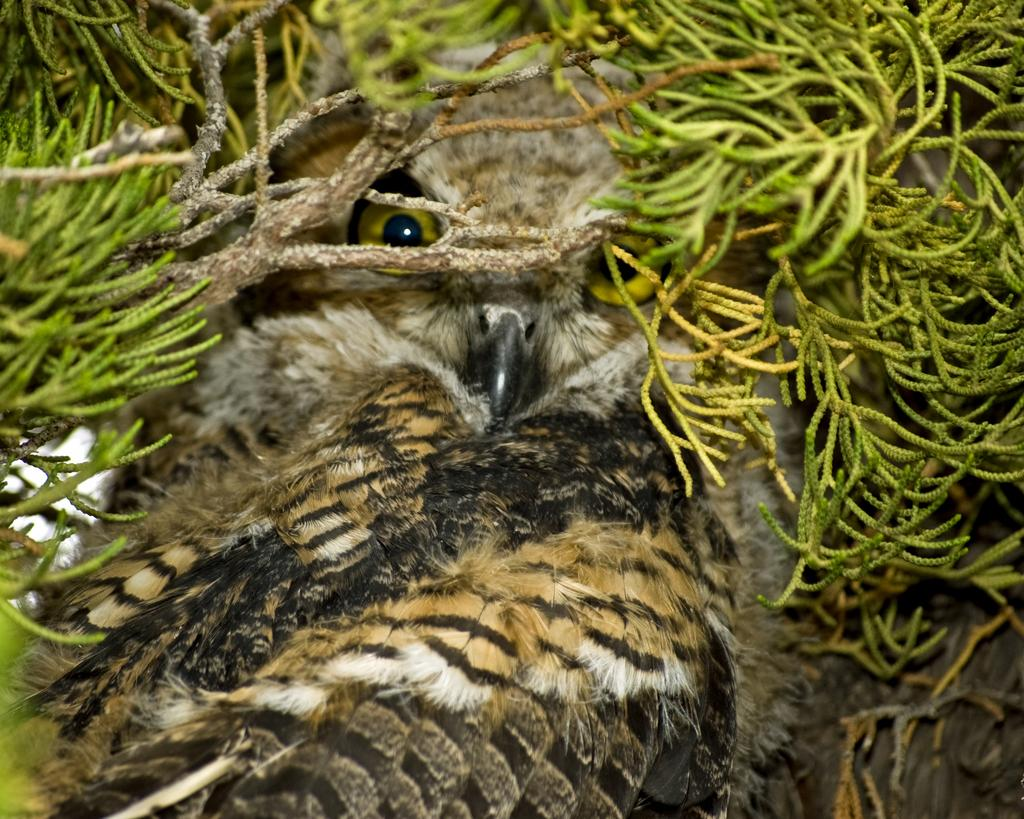What type of animal is in the image? There is an owl in the image. Where is the owl located in the image? The owl is in between the leaves of a tree. What color are the owl's feathers? The owl has brown feathers. Can you see any islands in the image? There are no islands present in the image. What type of vase is visible in the image? There is no vase present in the image. 